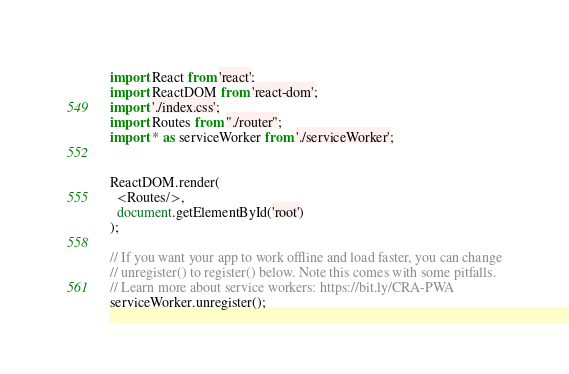<code> <loc_0><loc_0><loc_500><loc_500><_JavaScript_>import React from 'react';
import ReactDOM from 'react-dom';
import './index.css';
import Routes from "./router";
import * as serviceWorker from './serviceWorker';


ReactDOM.render(
  <Routes/>,
  document.getElementById('root')
);

// If you want your app to work offline and load faster, you can change
// unregister() to register() below. Note this comes with some pitfalls.
// Learn more about service workers: https://bit.ly/CRA-PWA
serviceWorker.unregister();
</code> 